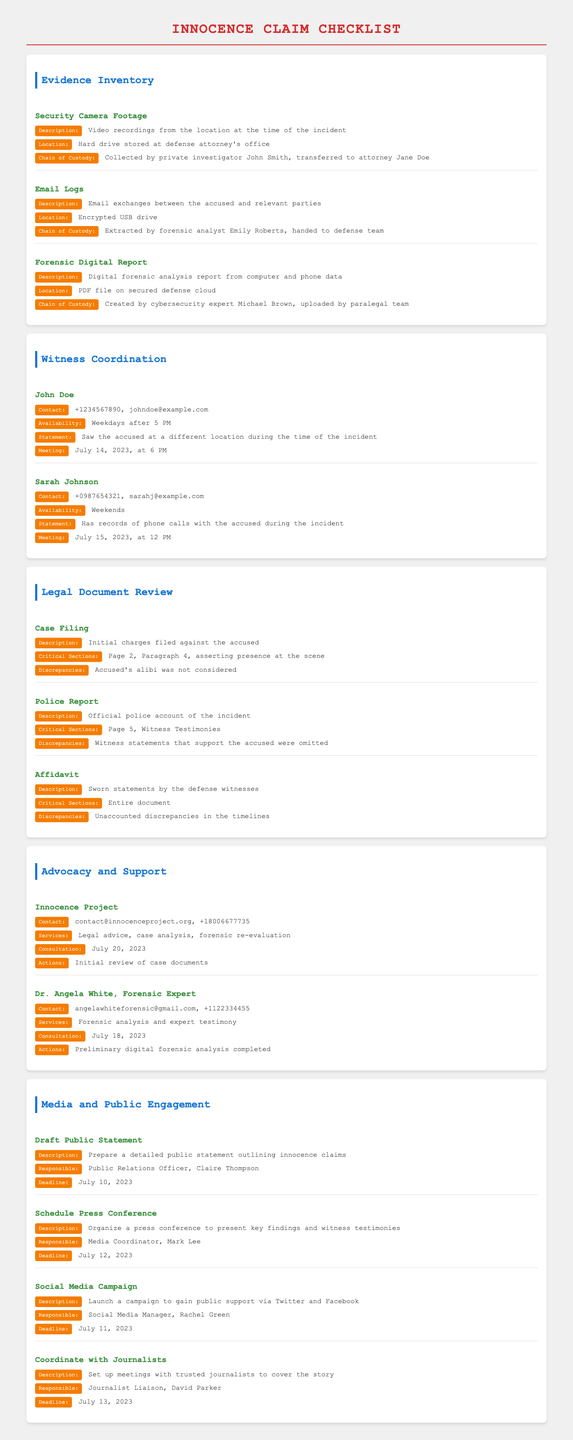What is the description of the Security Camera Footage? The description includes the video recordings from the location at the time of the incident.
Answer: Video recordings from the location at the time of the incident Who is the contact person for the Innocence Project? The contact person for the Innocence Project can be found in the Advocacy and Support section.
Answer: contact@innocenceproject.org What date is the meeting scheduled with John Doe? The meeting date is provided under the Witness Coordination section for John Doe.
Answer: July 14, 2023 What critical section is highlighted in the Police Report? The critical section can be located in the Legal Document Review area, mentioning witness testimonies.
Answer: Page 5, Witness Testimonies How many witnesses are listed in the Witness Coordination? The document lists the total number of witnesses in the Witness Coordination section.
Answer: 2 